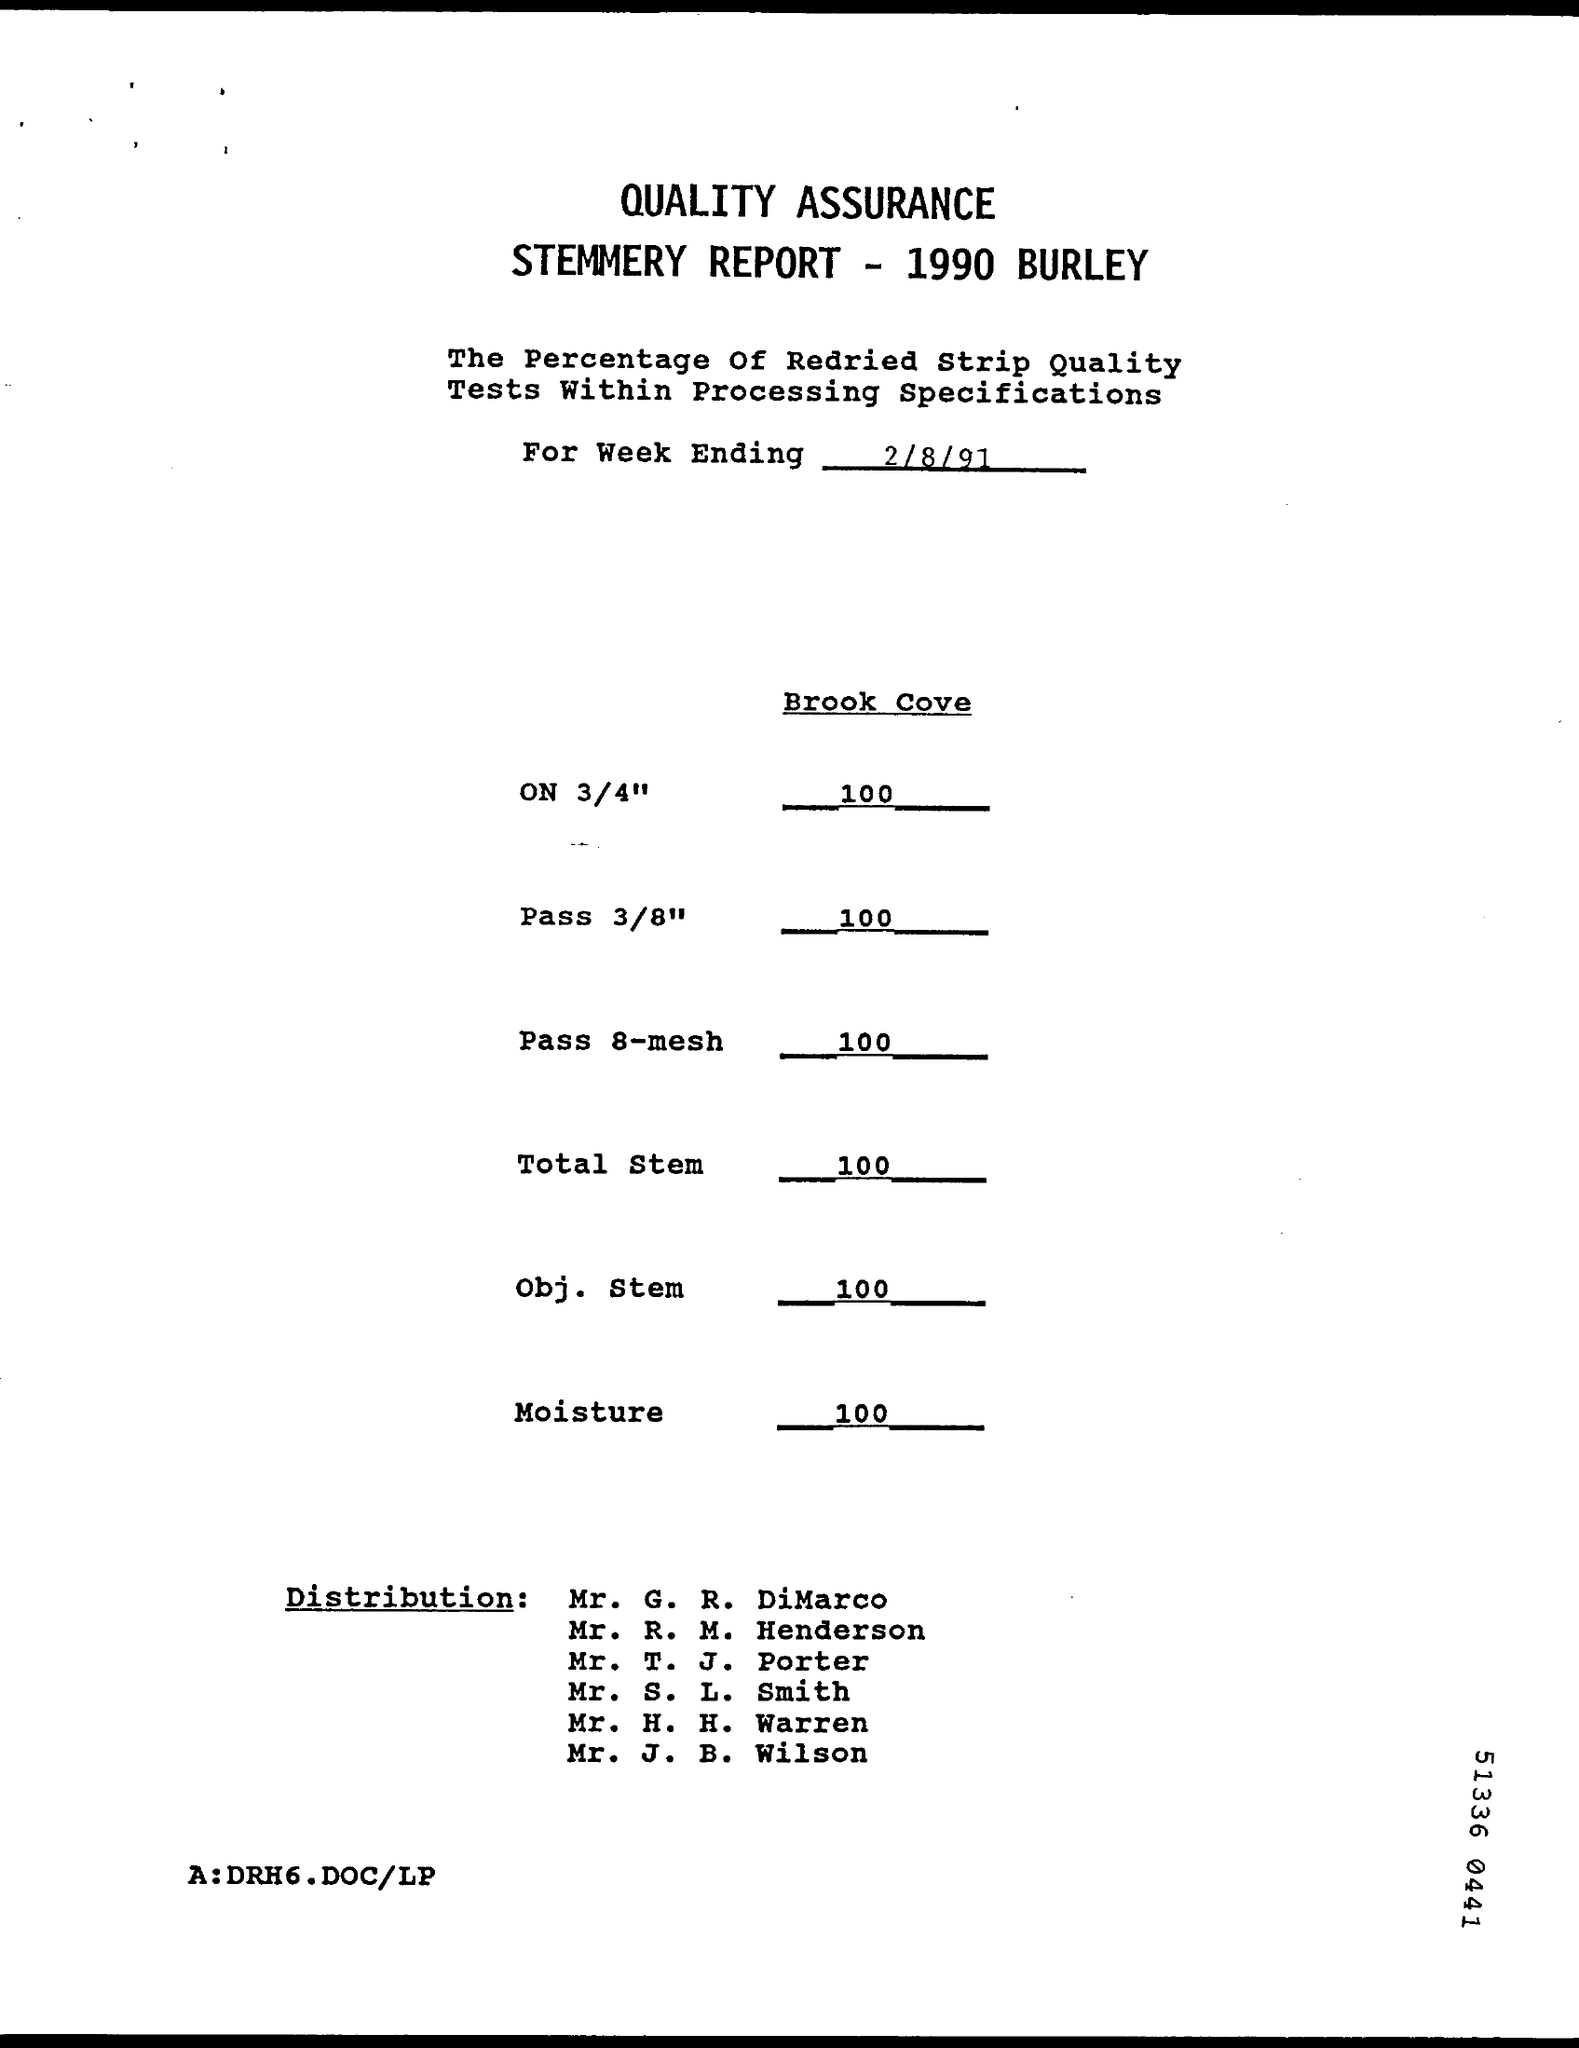What is the document title?
Provide a short and direct response. QUALITY ASSURANCE STEMMERY REPORT - 1990 BURLEY. What is the value of Moisture?
Offer a terse response. 100. What is the date given?
Offer a very short reply. 2/8/91. 